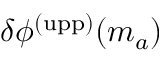<formula> <loc_0><loc_0><loc_500><loc_500>\delta \phi ^ { ( u p p ) } ( m _ { a } )</formula> 